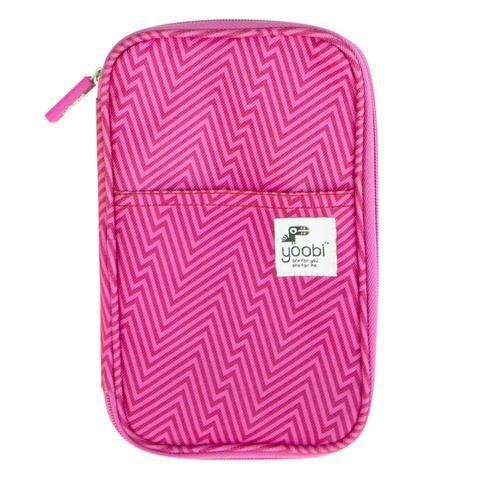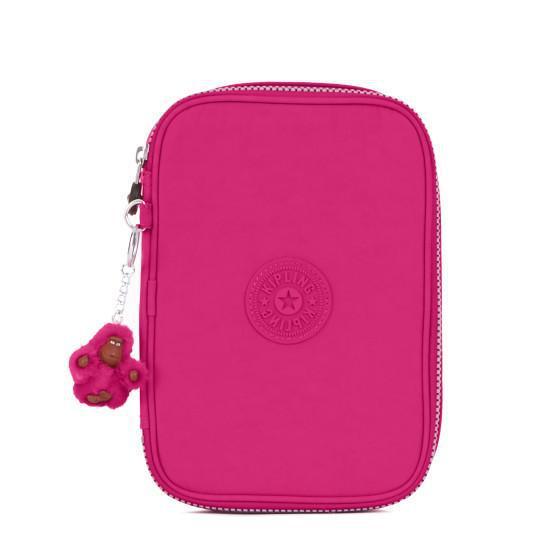The first image is the image on the left, the second image is the image on the right. Analyze the images presented: Is the assertion "Each image shows one zipper pencil case with rounded corners, and the cases in the left and right images are shown in the same position and configuration." valid? Answer yes or no. Yes. 